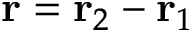Convert formula to latex. <formula><loc_0><loc_0><loc_500><loc_500>{ r } = { r } _ { 2 } - { r } _ { 1 }</formula> 